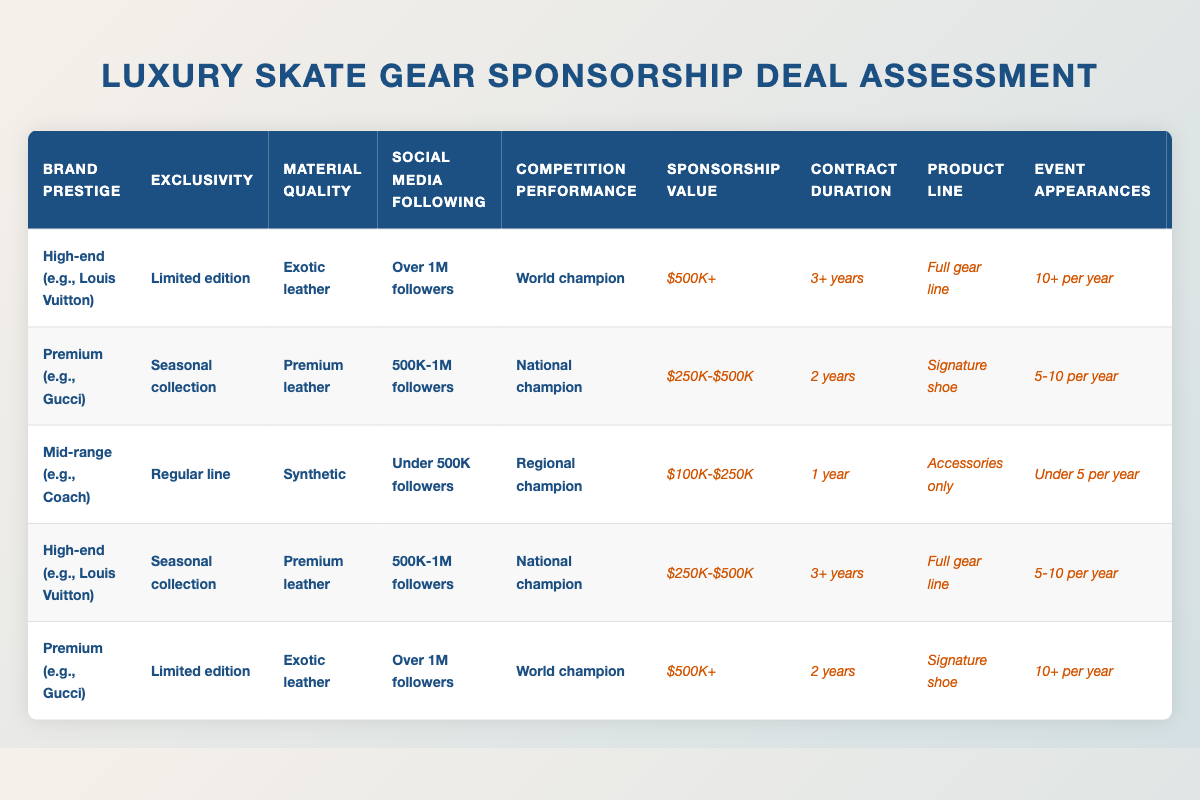What is the highest sponsorship value listed in the table? The table shows the sponsorship values across different rows. The highest value is "$500K+" which appears in two entries, one for High-end with Limited edition and Exotic leather for World champions with Over 1M followers and another for Premium with Limited edition and Exotic leather for World champions with Over 1M followers.
Answer: $500K+ What is the contract duration for the sponsorship deal associated with a National champion and Premium leather? In the table, I look for a combination of "National champion" and "Premium leather". Only one entry meets this criteria which is for Premium with Seasonal collection, giving a contract duration of "2 years".
Answer: 2 years How many different product lines are proposed in the sponsorship deals? The table includes three different product lines across various entries: "Full gear line", "Signature shoe", and "Accessories only". Counting these distinct product lines gives a total of three.
Answer: 3 Are there any deals that offer event appearances of under 5 per year? Checking the table, I find that there is one entry associated with "Mid-range (e.g., Coach)", which explicitly states "Under 5 per year". Therefore, there is at least one deal fitting this description.
Answer: Yes What is the average sponsorship value for all deals listed in the table? To calculate the average sponsorship value, convert the ranges to representative numbers: "$500K+" can be approximated as $500K, "$250K-$500K" as $375K, and "$100K-$250K" as $175K. There are two instances of $500K+, one instance of $375K, and one instance of $175K. The average is calculated as follows: (500 + 500 + 375 + 175) / 4 = 387.5. Thus, the average sponsorship value is approximately $387.5K.
Answer: $387.5K What marketing commitment is associated with the highest brand prestige? I look for entries labeled as "High-end (e.g., Louis Vuitton)" in the table. There are two such entries, and both have a social media commitment of "Weekly posts". Therefore, the answer pertains to the highest brand prestige.
Answer: Weekly posts 